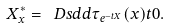Convert formula to latex. <formula><loc_0><loc_0><loc_500><loc_500>X ^ { * } _ { x } = \ D s d d { \tau _ { e ^ { - t X } } ( x ) } { t } { 0 } .</formula> 